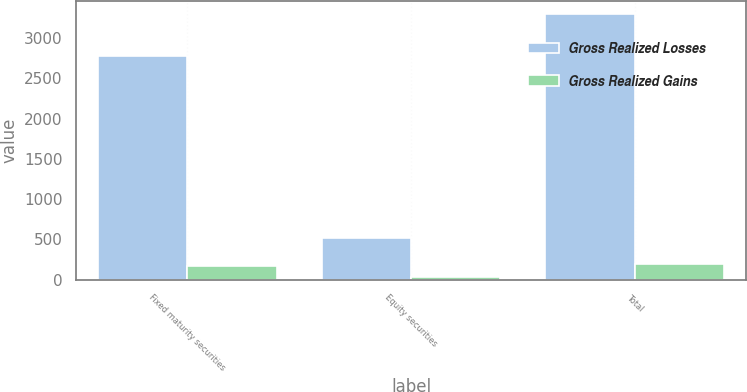Convert chart. <chart><loc_0><loc_0><loc_500><loc_500><stacked_bar_chart><ecel><fcel>Fixed maturity securities<fcel>Equity securities<fcel>Total<nl><fcel>Gross Realized Losses<fcel>2778<fcel>515<fcel>3293<nl><fcel>Gross Realized Gains<fcel>171<fcel>31<fcel>202<nl></chart> 